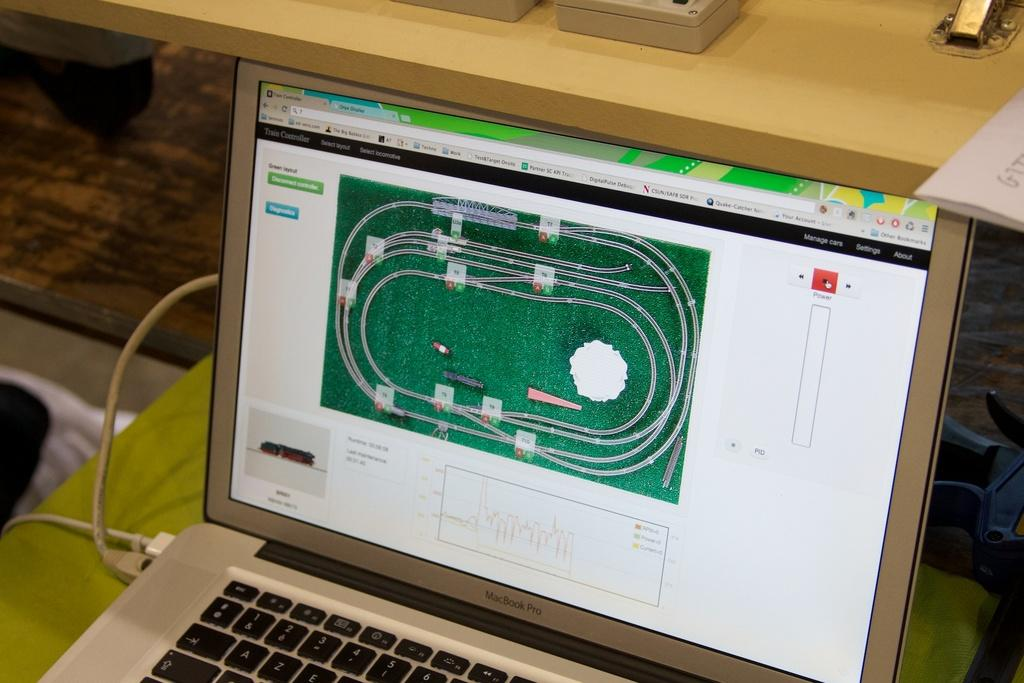<image>
Offer a succinct explanation of the picture presented. a MacBook Pro lap top computer with a green picture on the screen 